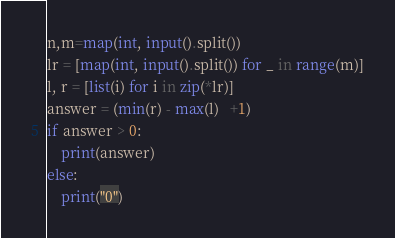<code> <loc_0><loc_0><loc_500><loc_500><_Python_>n,m=map(int, input().split())
lr = [map(int, input().split()) for _ in range(m)]
l, r = [list(i) for i in zip(*lr)]
answer = (min(r) - max(l)   +1) 
if answer > 0:
    print(answer)
else:
    print("0")</code> 